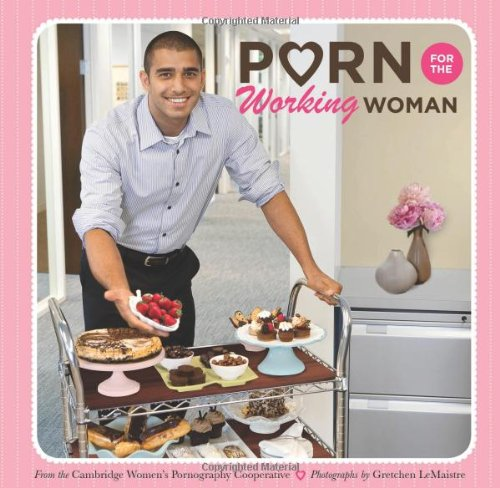What is the genre of this book? This book falls under the 'Humor & Entertainment' genre, primarily because it employs humor to discuss and portray everyday scenarios in a light-hearted, satirical way. 